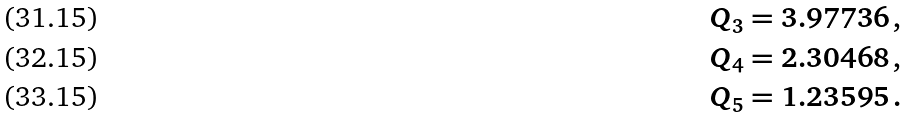<formula> <loc_0><loc_0><loc_500><loc_500>Q _ { 3 } & = 3 . 9 7 7 3 6 \, , \\ Q _ { 4 } & = 2 . 3 0 4 6 8 \, , \\ Q _ { 5 } & = 1 . 2 3 5 9 5 \, .</formula> 